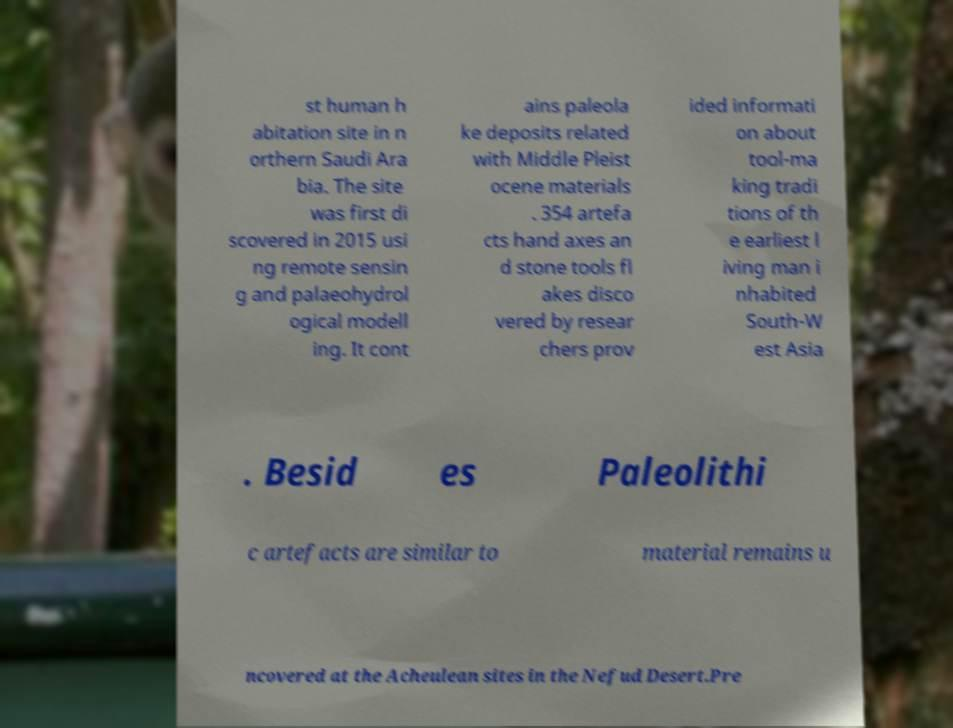Please identify and transcribe the text found in this image. st human h abitation site in n orthern Saudi Ara bia. The site was first di scovered in 2015 usi ng remote sensin g and palaeohydrol ogical modell ing. It cont ains paleola ke deposits related with Middle Pleist ocene materials . 354 artefa cts hand axes an d stone tools fl akes disco vered by resear chers prov ided informati on about tool-ma king tradi tions of th e earliest l iving man i nhabited South-W est Asia . Besid es Paleolithi c artefacts are similar to material remains u ncovered at the Acheulean sites in the Nefud Desert.Pre 